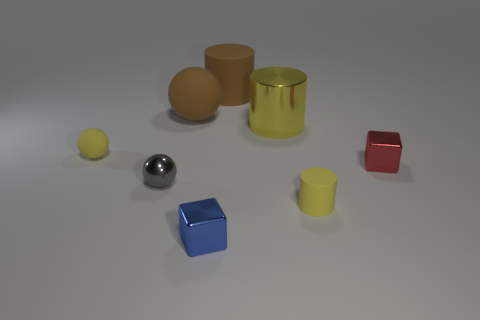Is the color of the big metal cylinder the same as the cylinder on the right side of the large metallic cylinder?
Your answer should be compact. Yes. Are there any spheres that have the same color as the large shiny thing?
Your response must be concise. Yes. There is another cylinder that is the same color as the large metallic cylinder; what is its material?
Offer a very short reply. Rubber. What size is the matte cylinder that is the same color as the small matte sphere?
Ensure brevity in your answer.  Small. Does the big sphere have the same color as the big rubber cylinder?
Your answer should be compact. Yes. What shape is the gray thing that is made of the same material as the large yellow object?
Keep it short and to the point. Sphere. There is a yellow object in front of the red block; what shape is it?
Keep it short and to the point. Cylinder. Do the cylinder that is on the left side of the metallic cylinder and the sphere that is behind the yellow sphere have the same color?
Your answer should be compact. Yes. How many cylinders are to the left of the tiny yellow cylinder and in front of the brown sphere?
Offer a very short reply. 1. The brown cylinder that is made of the same material as the tiny yellow sphere is what size?
Offer a terse response. Large. 